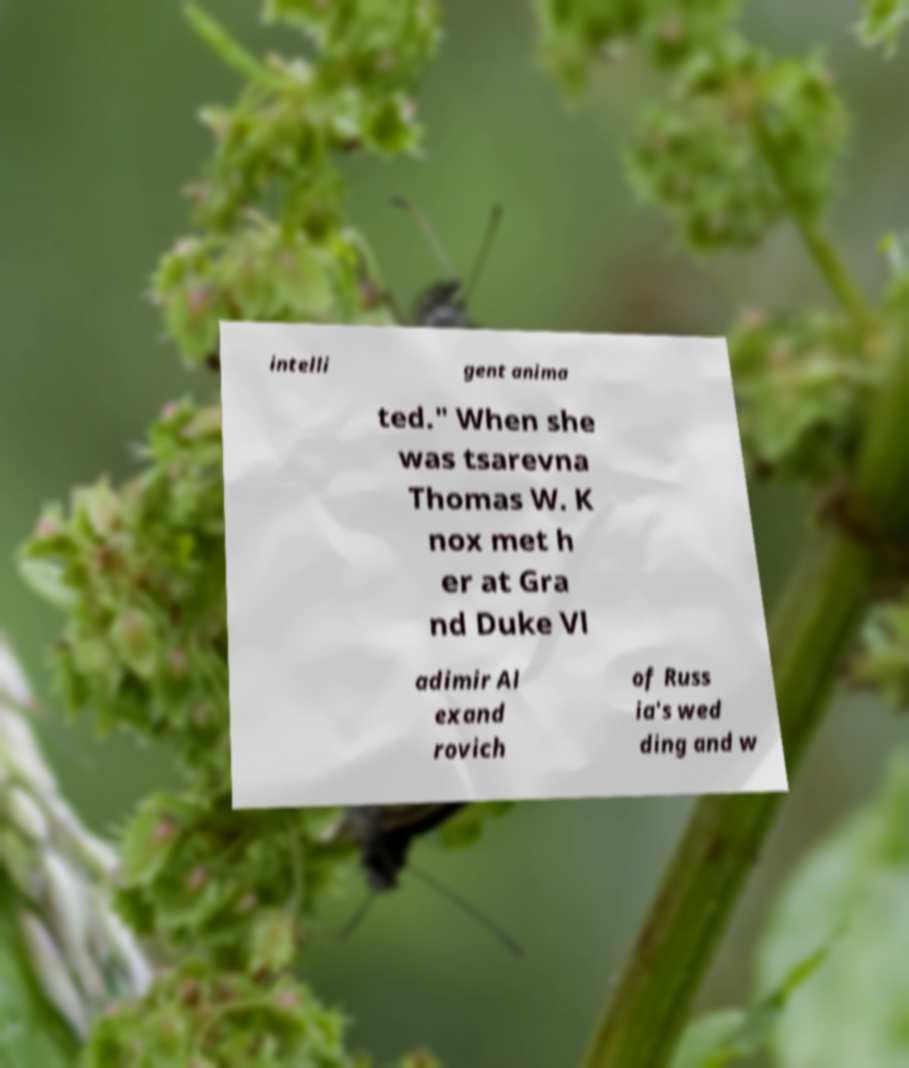I need the written content from this picture converted into text. Can you do that? intelli gent anima ted." When she was tsarevna Thomas W. K nox met h er at Gra nd Duke Vl adimir Al exand rovich of Russ ia's wed ding and w 